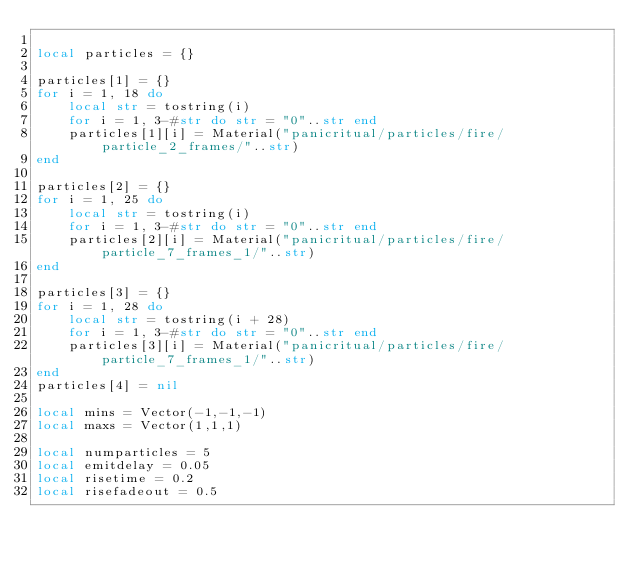<code> <loc_0><loc_0><loc_500><loc_500><_Lua_>
local particles = {}

particles[1] = {}
for i = 1, 18 do
	local str = tostring(i)
	for i = 1, 3-#str do str = "0"..str end
	particles[1][i] = Material("panicritual/particles/fire/particle_2_frames/"..str)
end

particles[2] = {}
for i = 1, 25 do
	local str = tostring(i)
	for i = 1, 3-#str do str = "0"..str end
	particles[2][i] = Material("panicritual/particles/fire/particle_7_frames_1/"..str)
end

particles[3] = {}
for i = 1, 28 do
	local str = tostring(i + 28)
	for i = 1, 3-#str do str = "0"..str end
	particles[3][i] = Material("panicritual/particles/fire/particle_7_frames_1/"..str)
end
particles[4] = nil

local mins = Vector(-1,-1,-1)
local maxs = Vector(1,1,1)

local numparticles = 5
local emitdelay = 0.05
local risetime = 0.2
local risefadeout = 0.5
</code> 